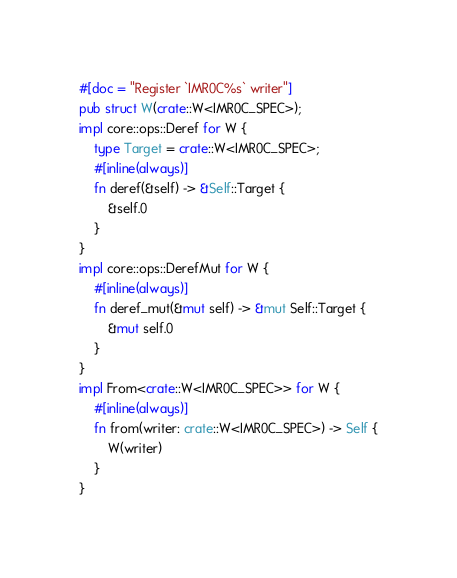<code> <loc_0><loc_0><loc_500><loc_500><_Rust_>#[doc = "Register `IMR0C%s` writer"]
pub struct W(crate::W<IMR0C_SPEC>);
impl core::ops::Deref for W {
    type Target = crate::W<IMR0C_SPEC>;
    #[inline(always)]
    fn deref(&self) -> &Self::Target {
        &self.0
    }
}
impl core::ops::DerefMut for W {
    #[inline(always)]
    fn deref_mut(&mut self) -> &mut Self::Target {
        &mut self.0
    }
}
impl From<crate::W<IMR0C_SPEC>> for W {
    #[inline(always)]
    fn from(writer: crate::W<IMR0C_SPEC>) -> Self {
        W(writer)
    }
}</code> 